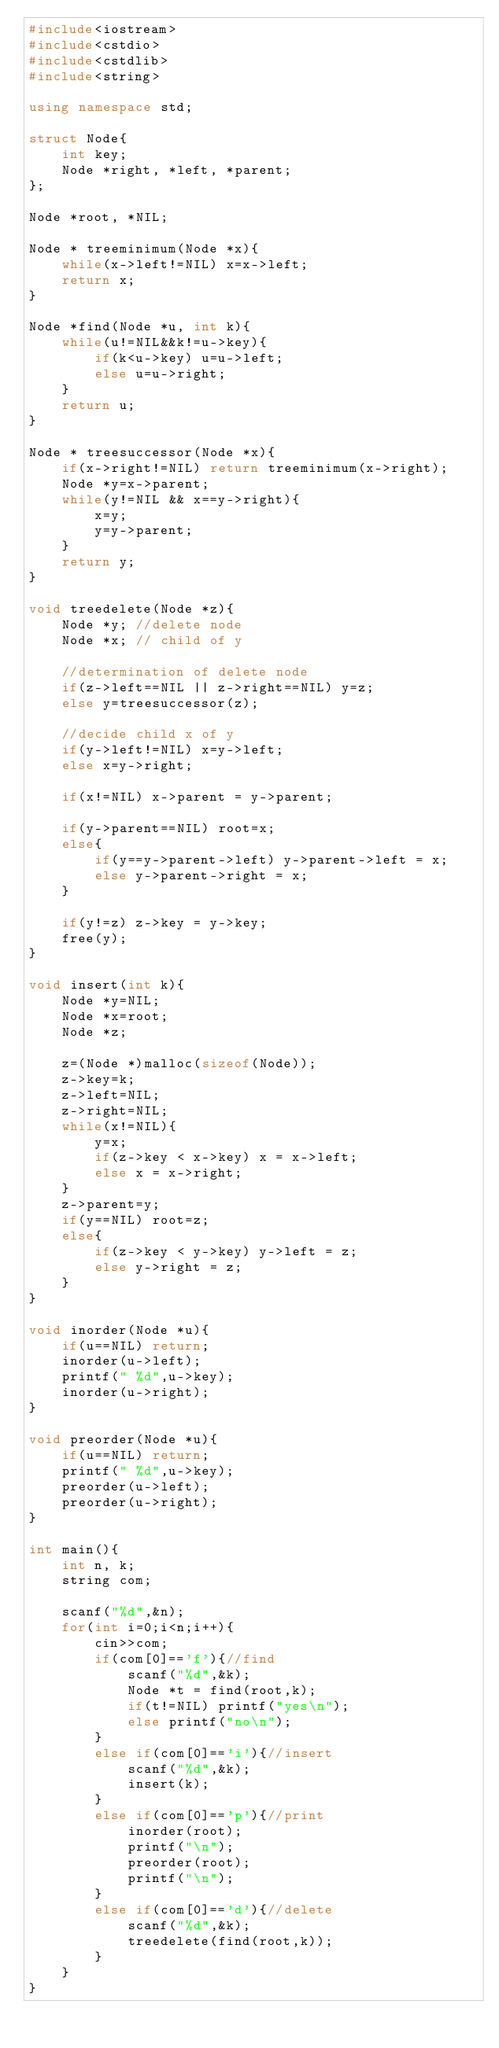<code> <loc_0><loc_0><loc_500><loc_500><_C++_>#include<iostream>
#include<cstdio>
#include<cstdlib>
#include<string>

using namespace std;

struct Node{
	int key;
	Node *right, *left, *parent;
};

Node *root, *NIL;

Node * treeminimum(Node *x){
	while(x->left!=NIL) x=x->left;
	return x;
}

Node *find(Node *u, int k){
	while(u!=NIL&&k!=u->key){
		if(k<u->key) u=u->left;
		else u=u->right;
	}
	return u;
}

Node * treesuccessor(Node *x){
	if(x->right!=NIL) return treeminimum(x->right);
	Node *y=x->parent;
	while(y!=NIL && x==y->right){
		x=y;
		y=y->parent;
	}
	return y;
}

void treedelete(Node *z){
	Node *y; //delete node
	Node *x; // child of y
	
	//determination of delete node
	if(z->left==NIL || z->right==NIL) y=z;
	else y=treesuccessor(z);
	
	//decide child x of y
	if(y->left!=NIL) x=y->left;
	else x=y->right;
	
	if(x!=NIL) x->parent = y->parent;
	
	if(y->parent==NIL) root=x;
	else{
		if(y==y->parent->left) y->parent->left = x;
		else y->parent->right = x;
	}
	
	if(y!=z) z->key = y->key;
	free(y);
}

void insert(int k){
	Node *y=NIL;
	Node *x=root;
	Node *z;
	
	z=(Node *)malloc(sizeof(Node));
	z->key=k;
	z->left=NIL;
	z->right=NIL;
	while(x!=NIL){
		y=x;
		if(z->key < x->key) x = x->left;
		else x = x->right;
	}
	z->parent=y;
	if(y==NIL) root=z;
	else{
		if(z->key < y->key) y->left = z;
		else y->right = z;
	}
}

void inorder(Node *u){
	if(u==NIL) return;
	inorder(u->left);
	printf(" %d",u->key);
	inorder(u->right);
}

void preorder(Node *u){
	if(u==NIL) return;
	printf(" %d",u->key);
	preorder(u->left);
	preorder(u->right);
}

int main(){
	int n, k;
	string com;
	
	scanf("%d",&n);
	for(int i=0;i<n;i++){
		cin>>com;
		if(com[0]=='f'){//find
			scanf("%d",&k);
			Node *t = find(root,k);
			if(t!=NIL) printf("yes\n");
			else printf("no\n");
		}
		else if(com[0]=='i'){//insert
			scanf("%d",&k);
			insert(k);
		}
		else if(com[0]=='p'){//print
			inorder(root);
			printf("\n");
			preorder(root);
			printf("\n");
		}
		else if(com[0]=='d'){//delete
			scanf("%d",&k);
			treedelete(find(root,k));
		}
	}
}</code> 